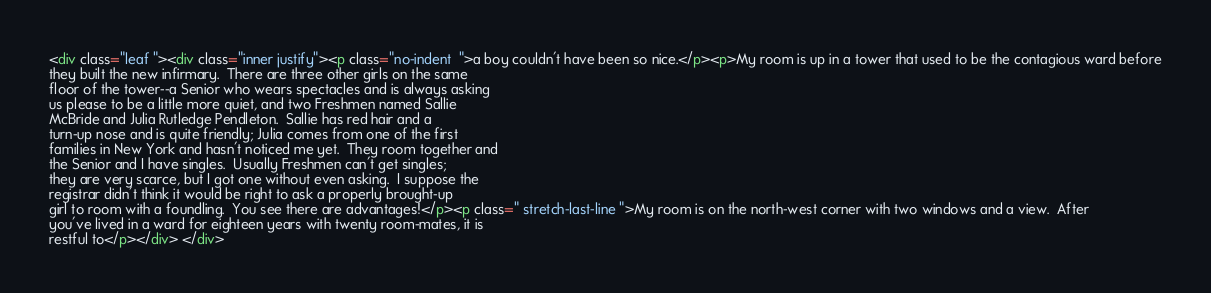Convert code to text. <code><loc_0><loc_0><loc_500><loc_500><_HTML_><div class="leaf "><div class="inner justify"><p class="no-indent  ">a boy couldn't have been so nice.</p><p>My room is up in a tower that used to be the contagious ward before
they built the new infirmary.  There are three other girls on the same
floor of the tower--a Senior who wears spectacles and is always asking
us please to be a little more quiet, and two Freshmen named Sallie
McBride and Julia Rutledge Pendleton.  Sallie has red hair and a
turn-up nose and is quite friendly; Julia comes from one of the first
families in New York and hasn't noticed me yet.  They room together and
the Senior and I have singles.  Usually Freshmen can't get singles;
they are very scarce, but I got one without even asking.  I suppose the
registrar didn't think it would be right to ask a properly brought-up
girl to room with a foundling.  You see there are advantages!</p><p class=" stretch-last-line ">My room is on the north-west corner with two windows and a view.  After
you've lived in a ward for eighteen years with twenty room-mates, it is
restful to</p></div> </div></code> 